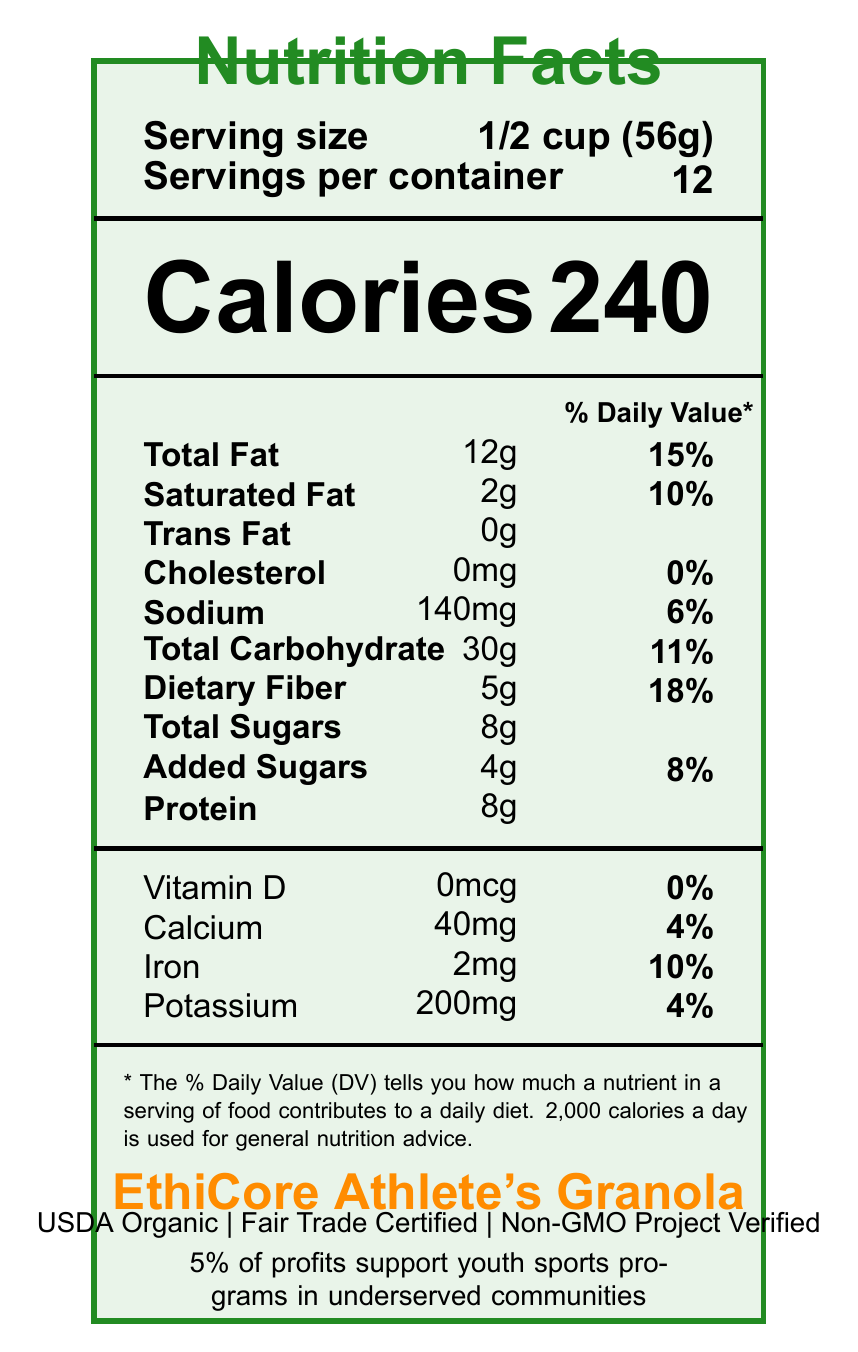what is the product name? The document clearly states the product name as "EthiCore Athlete's Granola".
Answer: EthiCore Athlete's Granola how many calories are in one serving? The document shows that each serving contains 240 calories.
Answer: 240 how much total fat is in one serving? The Nutrition Facts state that one serving has 12g of total fat.
Answer: 12g what percentage of daily value is the saturated fat? The document indicates that the saturated fat in one serving contributes to 10% of the daily value.
Answer: 10% how many servings are there per container? It is mentioned that there are 12 servings per container.
Answer: 12 how much dietary fiber does one serving provide? The Nutrition Facts list the dietary fiber content as 5g per serving.
Answer: 5g how much sodium does one serving contain? The sodium content per serving is 140mg according to the document.
Answer: 140mg which of the following certifications does EthiCore Athlete's Granola have? A. USDA Organic B. Fair Trade Certified C. Gluten-Free D. Non-GMO Project Verified The document lists USDA Organic, Fair Trade Certified, and Non-GMO Project Verified certifications, but not Gluten-Free.
Answer: C how many grams of protein are in one serving? A. 5g B. 8g C. 10g D. 12g The document specifies that one serving contains 8g of protein.
Answer: B does EthiCore Athlete's Granola contain any trans fat? The document shows that there are 0g of trans fat in one serving.
Answer: No what is the philanthropic impact noted on the document? According to the document, 5% of the profits go to support youth sports programs in underserved communities.
Answer: 5% of profits support youth sports programs in underserved communities what is the % Daily Value for total carbohydrate in one serving? The document indicates that the total carbohydrate in one serving is 11% of the daily value.
Answer: 11% how much iron does one serving of EthiCore Athlete's Granola contain? The Nutrition Facts state that one serving includes 2mg of iron.
Answer: 2mg what allergens are listed in the document? The document mentions that the granola contains tree nuts (almonds) and is produced in a facility that processes peanuts, soy, and milk.
Answer: Tree nuts (almonds) how is the packaging of EthiCore Athlete's Granola described in terms of sustainability? The document highlights that the packaging is made from 100% post-consumer recycled materials.
Answer: Packaging made from 100% post-consumer recycled materials who endorses EthiCore Athlete's Granola? The document indicates that the granola is endorsed by Megan Rapinoe.
Answer: Megan Rapinoe, professional soccer player and social activist what is the amount of added sugars in one serving? The document specifies that one serving contains 4g of added sugars.
Answer: 4g how much calcium is in one serving of EthiCore Athlete's Granola? The Nutrition Facts show that one serving includes 40mg of calcium.
Answer: 40mg how many vitamins and minerals are specifically listed with their % Daily Values? The document lists % Daily Values for Vitamin D, Calcium, Iron, and Potassium.
Answer: 4 what is the serving size of EthiCore Athlete's Granola? The document states that the serving size is 1/2 cup (56g).
Answer: 1/2 cup (56g) are all the ingredients in EthiCore Athlete's Granola organic? The document lists some ingredients as organic but does not specify if all ingredients are organic.
Answer: Cannot be determined summarize the main idea of the document. The document contains comprehensive details about the nutrition content, ingredients, endorsements, and the ethical and philanthropic aspects of Ethicore Athlete's Granola.
Answer: This document provides detailed Nutrition Facts, certifications, endorsement, and sustainability information for EthiCore Athlete's Granola. The granola is nutrient-dense, fair-trade certified, and supports youth sports initiatives. 